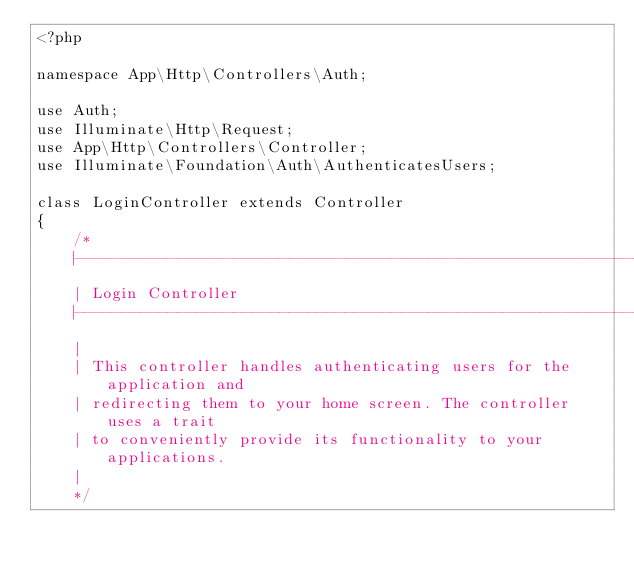<code> <loc_0><loc_0><loc_500><loc_500><_PHP_><?php

namespace App\Http\Controllers\Auth;

use Auth;
use Illuminate\Http\Request;
use App\Http\Controllers\Controller;
use Illuminate\Foundation\Auth\AuthenticatesUsers;

class LoginController extends Controller
{
    /*
    |--------------------------------------------------------------------------
    | Login Controller
    |--------------------------------------------------------------------------
    |
    | This controller handles authenticating users for the application and
    | redirecting them to your home screen. The controller uses a trait
    | to conveniently provide its functionality to your applications.
    |
    */
</code> 